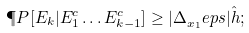Convert formula to latex. <formula><loc_0><loc_0><loc_500><loc_500>\P P [ E _ { k } | E _ { 1 } ^ { c } \dots E _ { k - 1 } ^ { c } ] \geq | \Delta _ { x _ { 1 } } ^ { \ } e p s | { \hat { h } } ;</formula> 